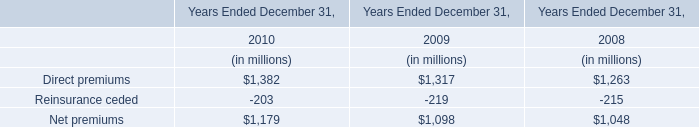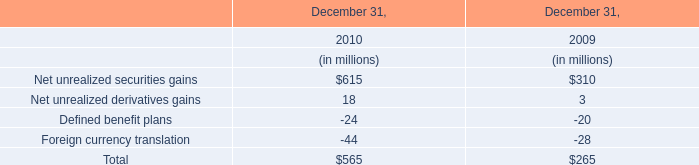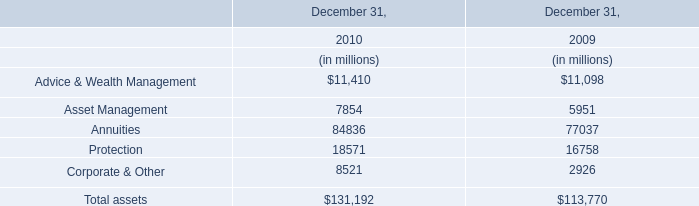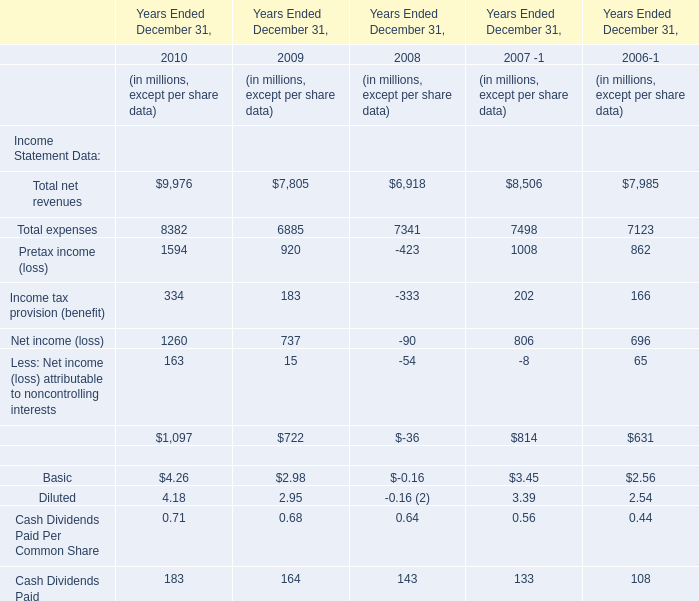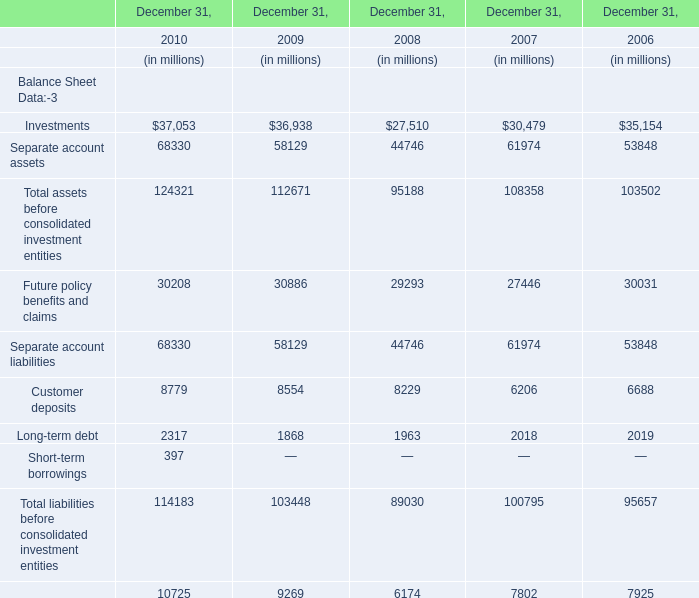what was the cumulative stock option compensation expense was recognized due to qualifying termination eligibility preceding the requisite vesting period from 2014 to 2016 in millions 
Computations: ((2 + 2) + 1)
Answer: 5.0. 